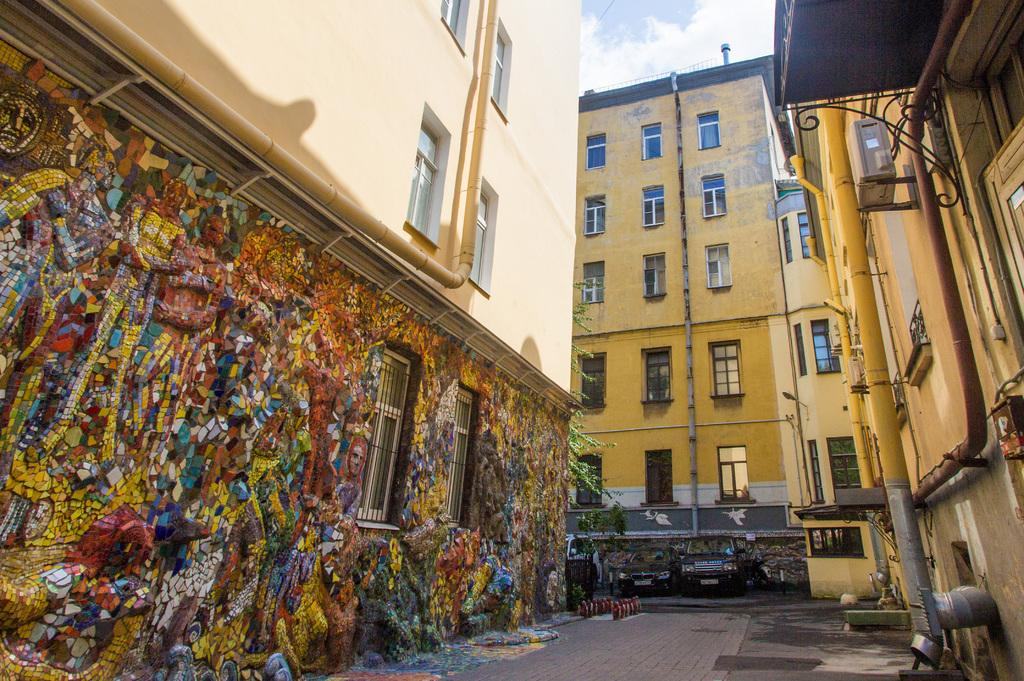What type of structures can be seen in the image? There are buildings in the image. What else can be seen in the image besides the buildings? There are parked vehicles in the image. What is visible at the top of the image? The sky is visible at the top of the image and appears to be clear. How many rats can be seen playing with the girls in the image? There are no rats or girls present in the image. What form does the ice cream take in the image? There is no ice cream present in the image. 